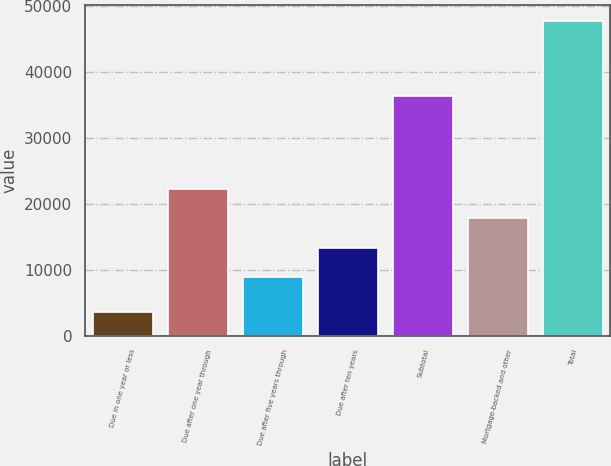<chart> <loc_0><loc_0><loc_500><loc_500><bar_chart><fcel>Due in one year or less<fcel>Due after one year through<fcel>Due after five years through<fcel>Due after ten years<fcel>Subtotal<fcel>Mortgage-backed and other<fcel>Total<nl><fcel>3564.2<fcel>22190.2<fcel>8944.9<fcel>13360<fcel>36412.1<fcel>17775.1<fcel>47715.3<nl></chart> 